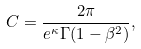Convert formula to latex. <formula><loc_0><loc_0><loc_500><loc_500>C = \frac { 2 \pi } { e ^ { \kappa } \Gamma ( 1 - \beta ^ { 2 } ) } ,</formula> 